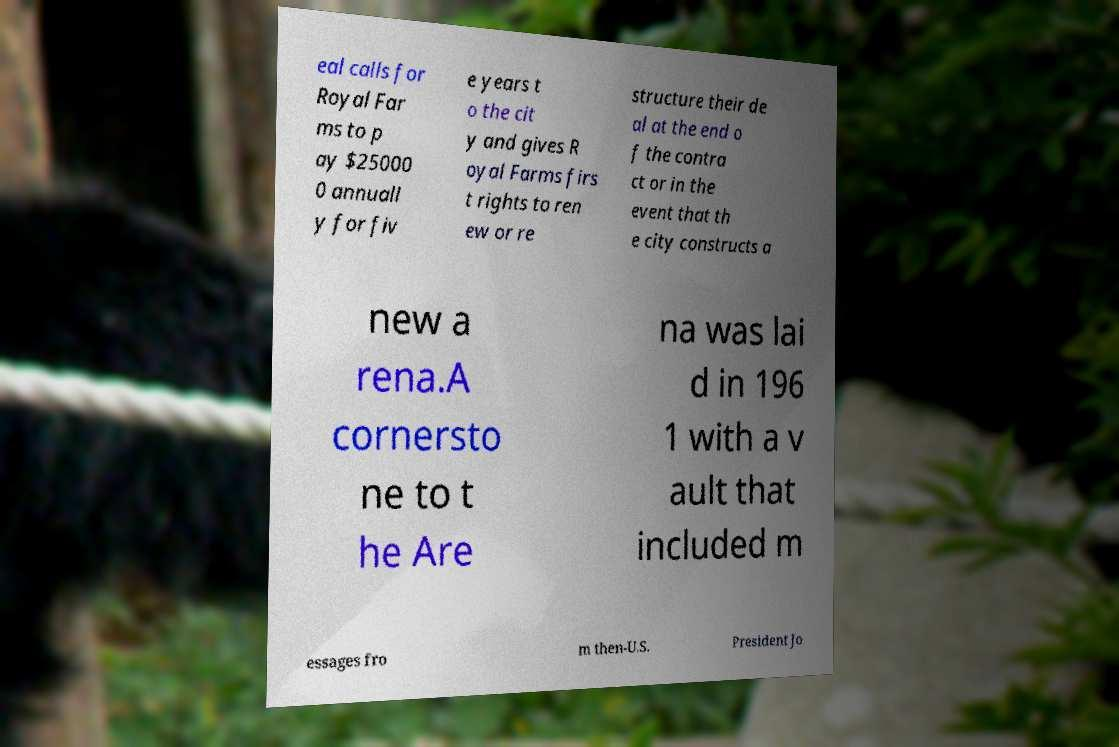What messages or text are displayed in this image? I need them in a readable, typed format. eal calls for Royal Far ms to p ay $25000 0 annuall y for fiv e years t o the cit y and gives R oyal Farms firs t rights to ren ew or re structure their de al at the end o f the contra ct or in the event that th e city constructs a new a rena.A cornersto ne to t he Are na was lai d in 196 1 with a v ault that included m essages fro m then-U.S. President Jo 